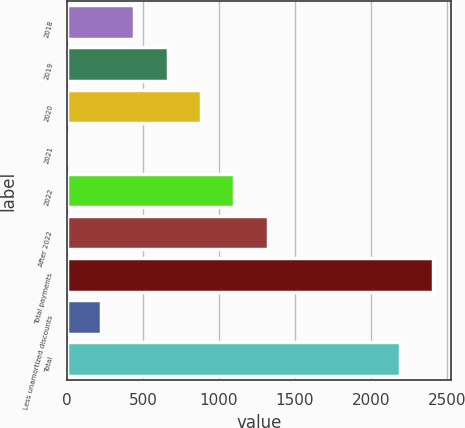Convert chart to OTSL. <chart><loc_0><loc_0><loc_500><loc_500><bar_chart><fcel>2018<fcel>2019<fcel>2020<fcel>2021<fcel>2022<fcel>After 2022<fcel>Total payments<fcel>Less unamortized discounts<fcel>Total<nl><fcel>442.18<fcel>661.92<fcel>881.66<fcel>2.7<fcel>1101.4<fcel>1321.14<fcel>2408.04<fcel>222.44<fcel>2188.3<nl></chart> 